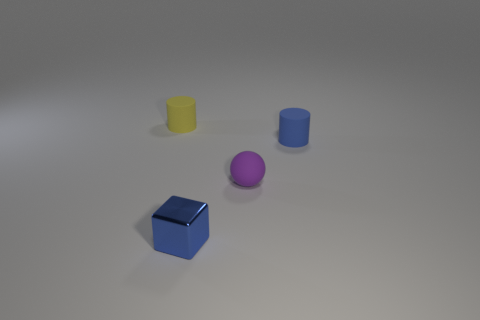There is a tiny cube that is in front of the matte sphere; what is its color?
Your answer should be very brief. Blue. What number of gray objects are either small matte spheres or blocks?
Offer a terse response. 0. The tiny rubber sphere is what color?
Your answer should be very brief. Purple. Is there any other thing that has the same material as the small yellow cylinder?
Provide a succinct answer. Yes. Is the number of yellow cylinders that are on the left side of the yellow cylinder less than the number of matte balls left of the small metallic object?
Offer a very short reply. No. The rubber thing that is both behind the purple rubber object and on the right side of the blue metal block has what shape?
Your answer should be very brief. Cylinder. What number of other matte things have the same shape as the blue rubber object?
Provide a short and direct response. 1. There is a yellow cylinder that is made of the same material as the purple object; what is its size?
Provide a succinct answer. Small. How many other matte objects are the same size as the yellow object?
Provide a short and direct response. 2. There is a matte cylinder that is the same color as the small block; what size is it?
Offer a terse response. Small. 